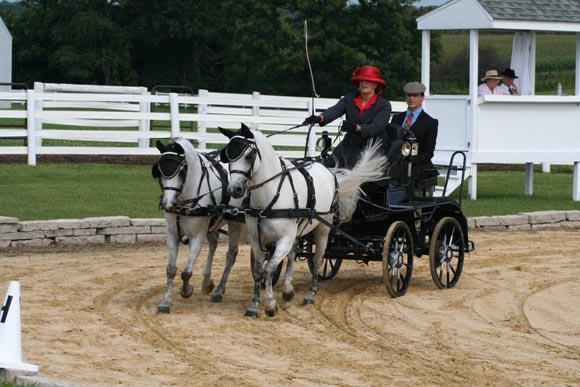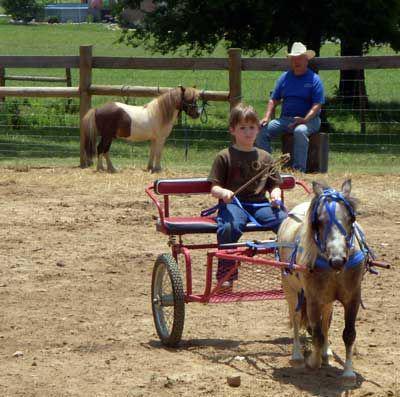The first image is the image on the left, the second image is the image on the right. For the images displayed, is the sentence "There are more than two people being pulled by a horse." factually correct? Answer yes or no. Yes. The first image is the image on the left, the second image is the image on the right. Examine the images to the left and right. Is the description "Each image depicts one person sitting in a cart pulled by a single pony or horse." accurate? Answer yes or no. No. 